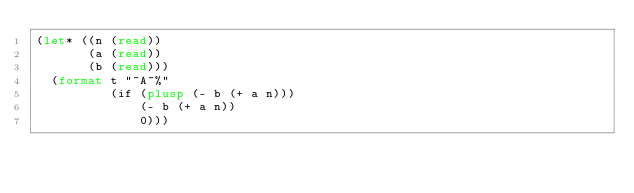<code> <loc_0><loc_0><loc_500><loc_500><_Lisp_>(let* ((n (read))
       (a (read))
       (b (read)))
  (format t "~A~%"
          (if (plusp (- b (+ a n)))
              (- b (+ a n))
              0)))</code> 